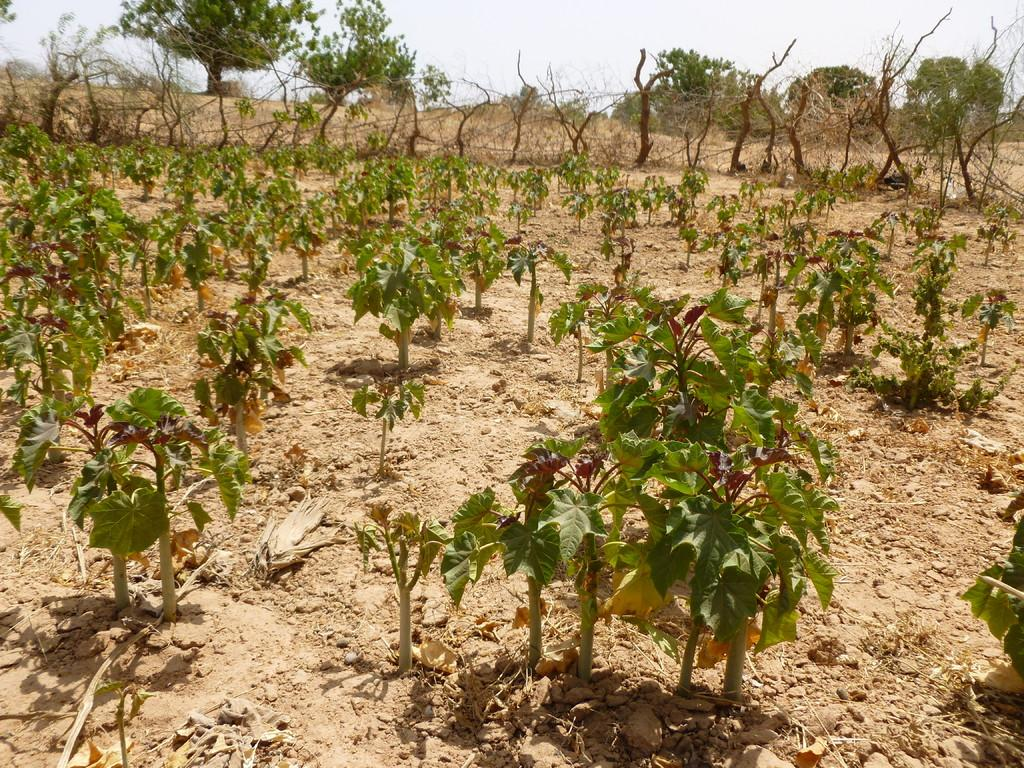What type of living organisms can be seen in the image? Plants and a tree are visible in the image. What is visible at the top of the image? The sky is visible at the top of the image. What type of food is being cooked in the image? There is no food or cooking activity present in the image. How many burn marks can be seen on the tree in the image? There are no burn marks visible on the tree in the image. 